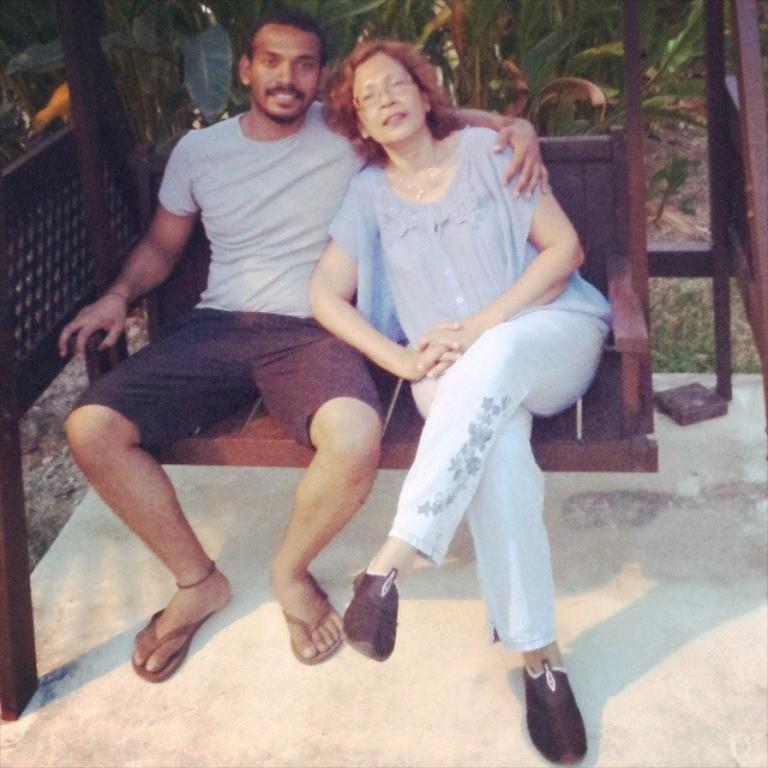What are the two persons in the image doing? The two persons are sitting on a swing in the image. What can be seen in the background of the image? There is grass and plants in the background of the image. What shape is the holiday border in the image? There is no holiday border present in the image. 